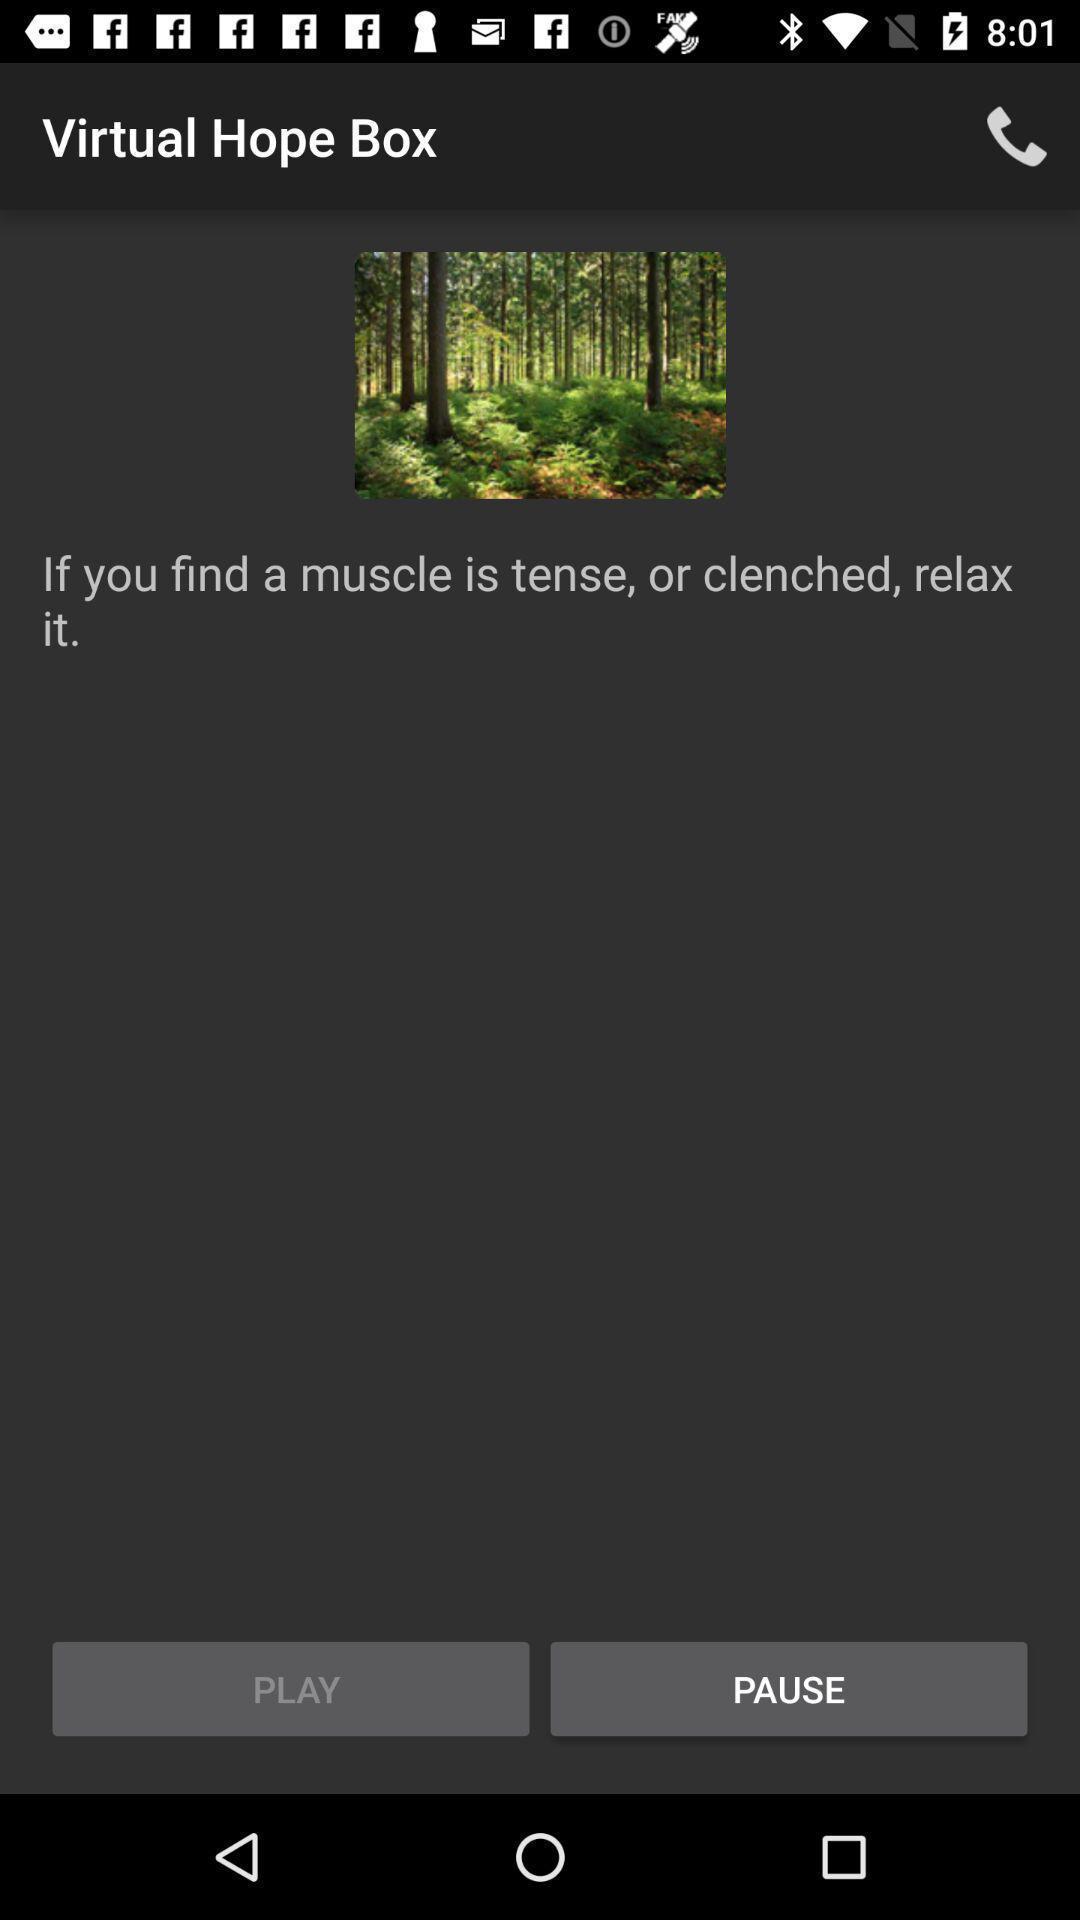Provide a textual representation of this image. Screen displaying greenery image on health care app. 